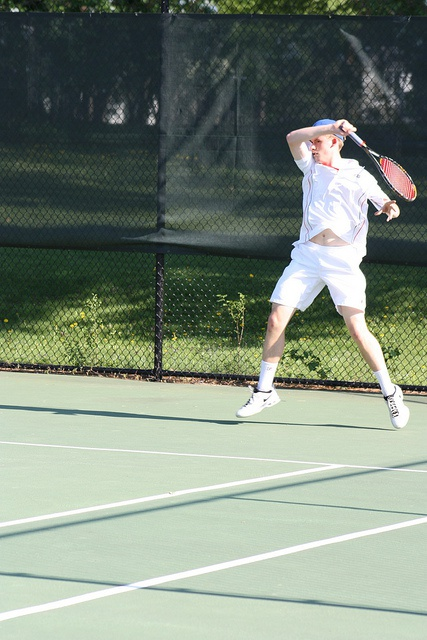Describe the objects in this image and their specific colors. I can see people in darkgreen, lavender, darkgray, lightpink, and black tones and tennis racket in darkgreen, lightpink, lightgray, gray, and black tones in this image. 